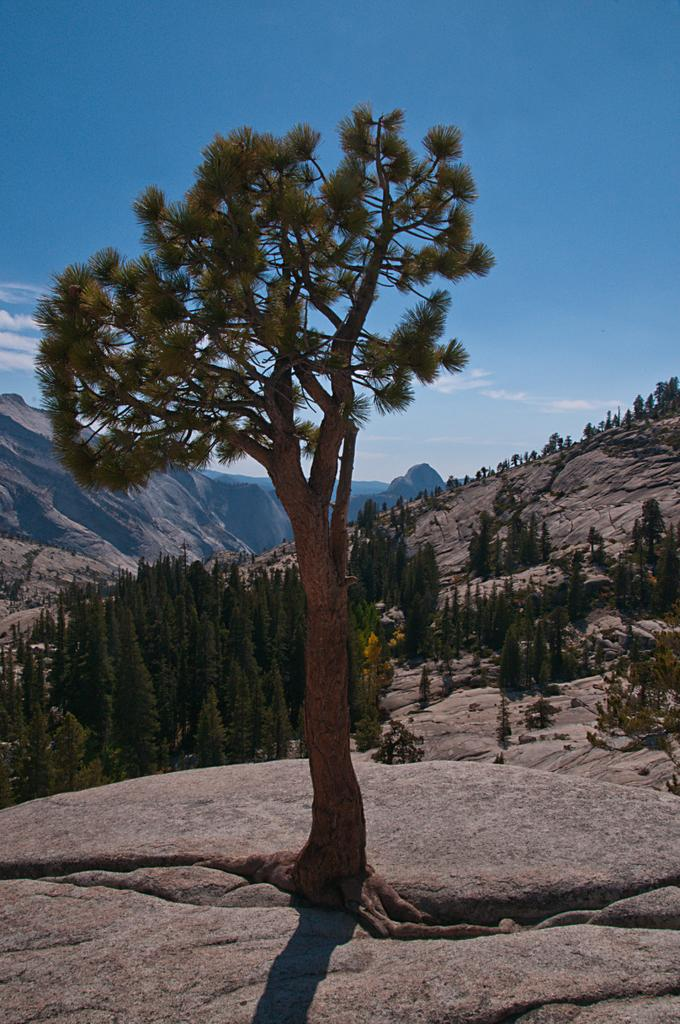What is the main subject in the center of the image? There is a tree in the center of the image. What can be seen in the background of the image? There are trees and a rock in the background of the image. What is visible in the sky in the background of the image? The sky is visible in the background of the image, and clouds are present. How many sisters are visible in the image? There are no sisters present in the image; it features a tree, trees in the background, a rock, and the sky. What type of salt can be seen on the tree in the image? There is no salt present on the tree or anywhere else in the image. 